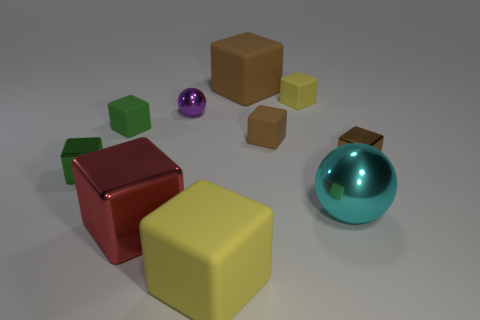Can you create a story based on the arrangement of these objects? Certainly, the image could depict a moment frozen in time within a toy factory's testing room. The larger yellow cube at the front might be the curious leader, inching closer to observe the red cube that's been singled out for its unique, metallic luster. The two smaller cubes are sidekick explorers, trailing behind the scene, flanked by the mysterious purple sphere as a sort of otherworldly guide. In the corner, trying to remain unnoticed, the turquoise sphere glows behind the green cylindrical sentry, while the larger green cube stands guard like a stoic warden of the assembly. 